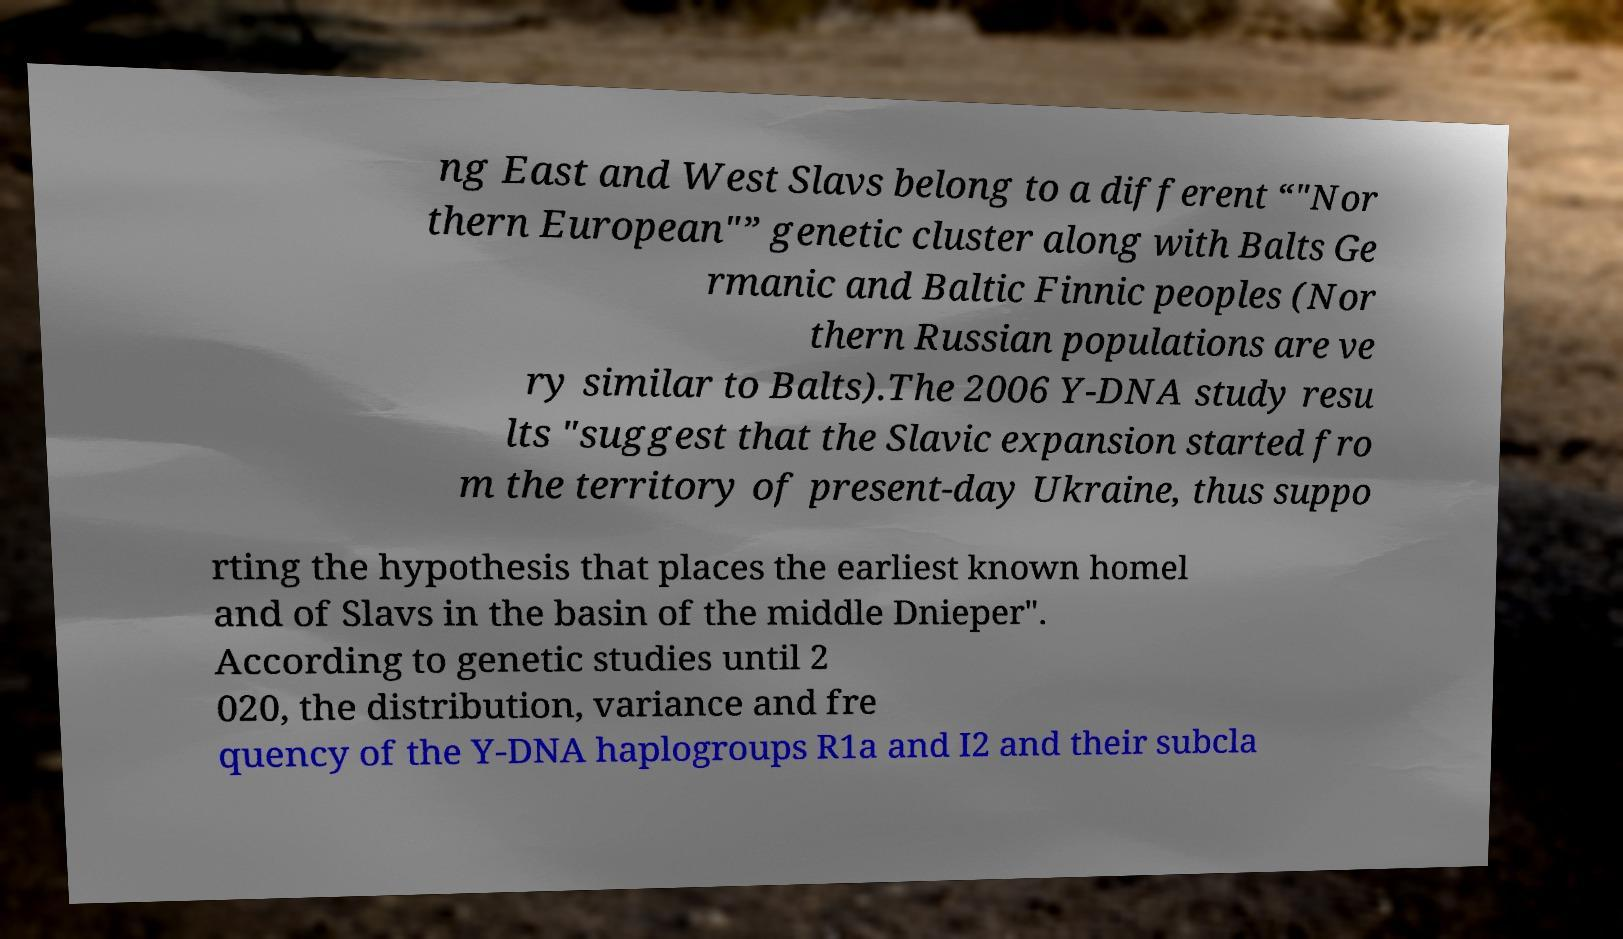There's text embedded in this image that I need extracted. Can you transcribe it verbatim? ng East and West Slavs belong to a different “"Nor thern European"” genetic cluster along with Balts Ge rmanic and Baltic Finnic peoples (Nor thern Russian populations are ve ry similar to Balts).The 2006 Y-DNA study resu lts "suggest that the Slavic expansion started fro m the territory of present-day Ukraine, thus suppo rting the hypothesis that places the earliest known homel and of Slavs in the basin of the middle Dnieper". According to genetic studies until 2 020, the distribution, variance and fre quency of the Y-DNA haplogroups R1a and I2 and their subcla 